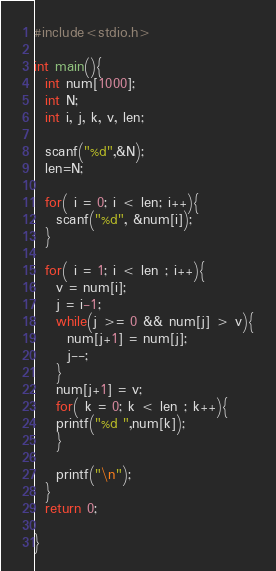Convert code to text. <code><loc_0><loc_0><loc_500><loc_500><_C_>#include<stdio.h>

int main(){
  int num[1000];
  int N;
  int i, j, k, v, len;  
  
  scanf("%d",&N);
  len=N;
    
  for( i = 0; i < len; i++){
    scanf("%d", &num[i]);
  }
  
  for( i = 1; i < len ; i++){
    v = num[i];
    j = i-1;
    while(j >= 0 && num[j] > v){
      num[j+1] = num[j];
      j--;
    }
    num[j+1] = v;
    for( k = 0; k < len ; k++){
    printf("%d ",num[k]);
    }
    
    printf("\n");
  }
  return 0;

}</code> 